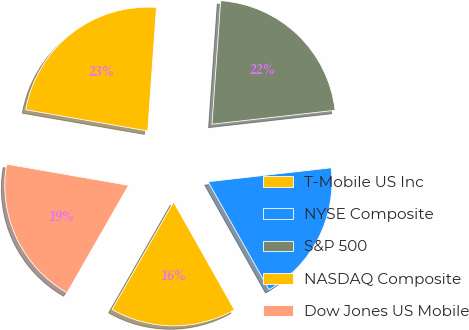Convert chart to OTSL. <chart><loc_0><loc_0><loc_500><loc_500><pie_chart><fcel>T-Mobile US Inc<fcel>NYSE Composite<fcel>S&P 500<fcel>NASDAQ Composite<fcel>Dow Jones US Mobile<nl><fcel>16.45%<fcel>18.62%<fcel>22.09%<fcel>23.38%<fcel>19.46%<nl></chart> 